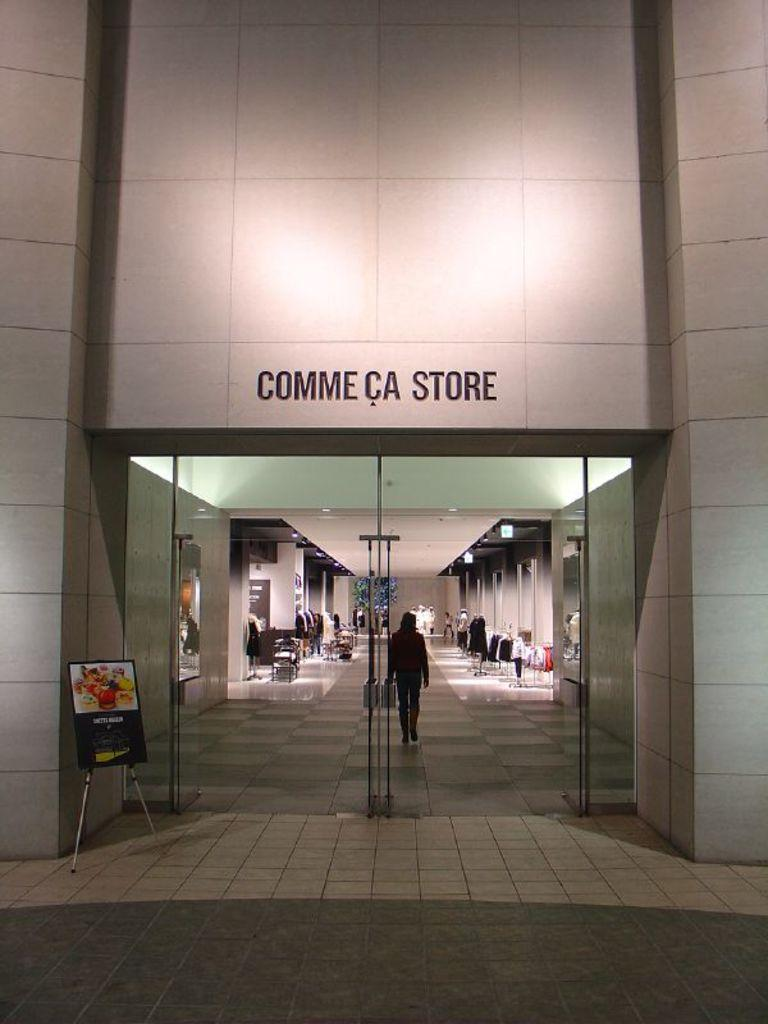What type of structure is present in the image? There is a building in the image. What type of entrance can be seen in the image? There is a glass door in the image. What is located near the glass door? There is a board and a stand in the image. What items are visible on the stand? Clothes are visible in the image. Is there any human presence in the image? Yes, there is a person walking in the image. What type of plot is being developed in the image? There is no plot being developed in the image; it is a static scene featuring a building, glass door, board, stand, clothes, and a person walking. What kind of cable can be seen connecting the board and the stand in the image? There is no cable connecting the board and the stand in the image. 